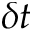Convert formula to latex. <formula><loc_0><loc_0><loc_500><loc_500>\delta t</formula> 